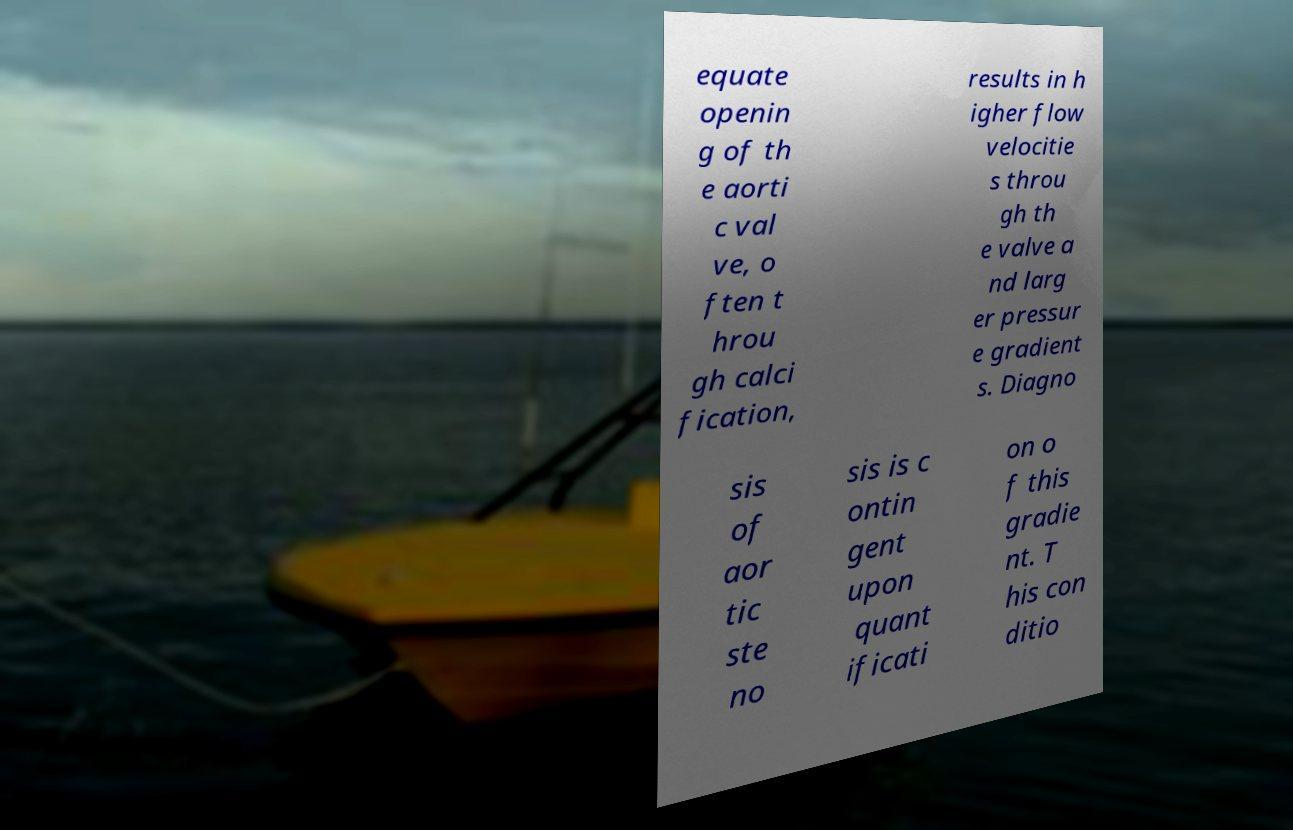I need the written content from this picture converted into text. Can you do that? equate openin g of th e aorti c val ve, o ften t hrou gh calci fication, results in h igher flow velocitie s throu gh th e valve a nd larg er pressur e gradient s. Diagno sis of aor tic ste no sis is c ontin gent upon quant ificati on o f this gradie nt. T his con ditio 